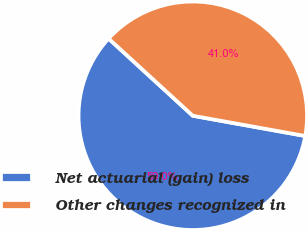<chart> <loc_0><loc_0><loc_500><loc_500><pie_chart><fcel>Net actuarial (gain) loss<fcel>Other changes recognized in<nl><fcel>58.97%<fcel>41.03%<nl></chart> 